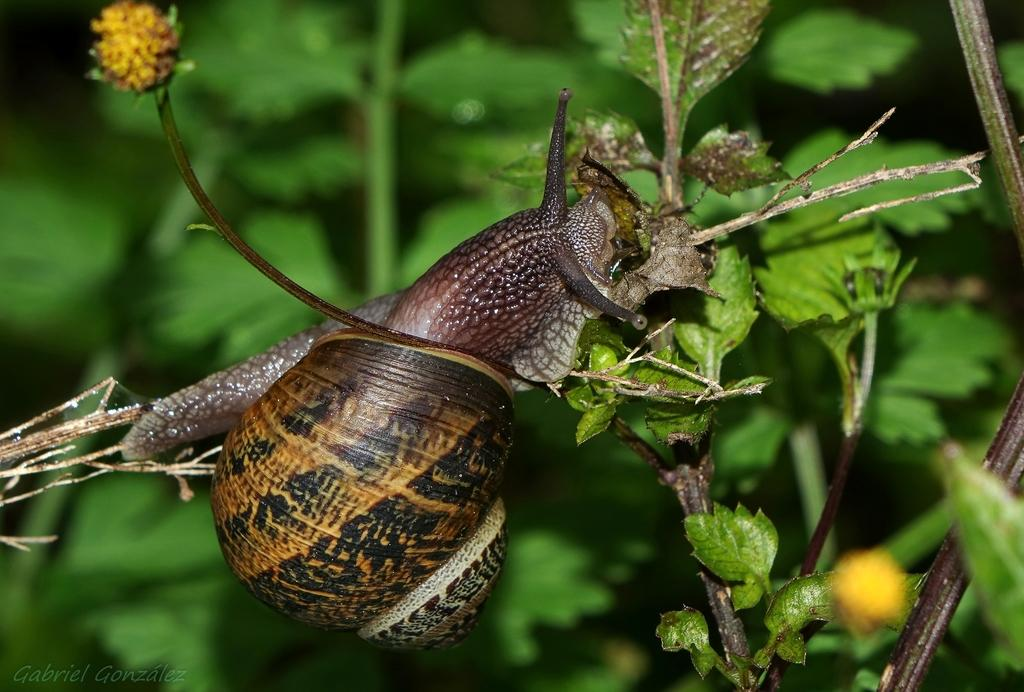What is located on the left side of the image? There is a cocoon on the left side of the image. Can you describe the position of the cocoon? The cocoon is on a stem. What can be seen on the right side of the image? There is a plant on the right side of the image. What type of impulse can be seen affecting the cocoon in the image? There is no impulse affecting the cocoon in the image; it is stationary on the stem. What is being served for dinner in the image? There is no dinner or food present in the image; it features a cocoon on a stem and a plant. 